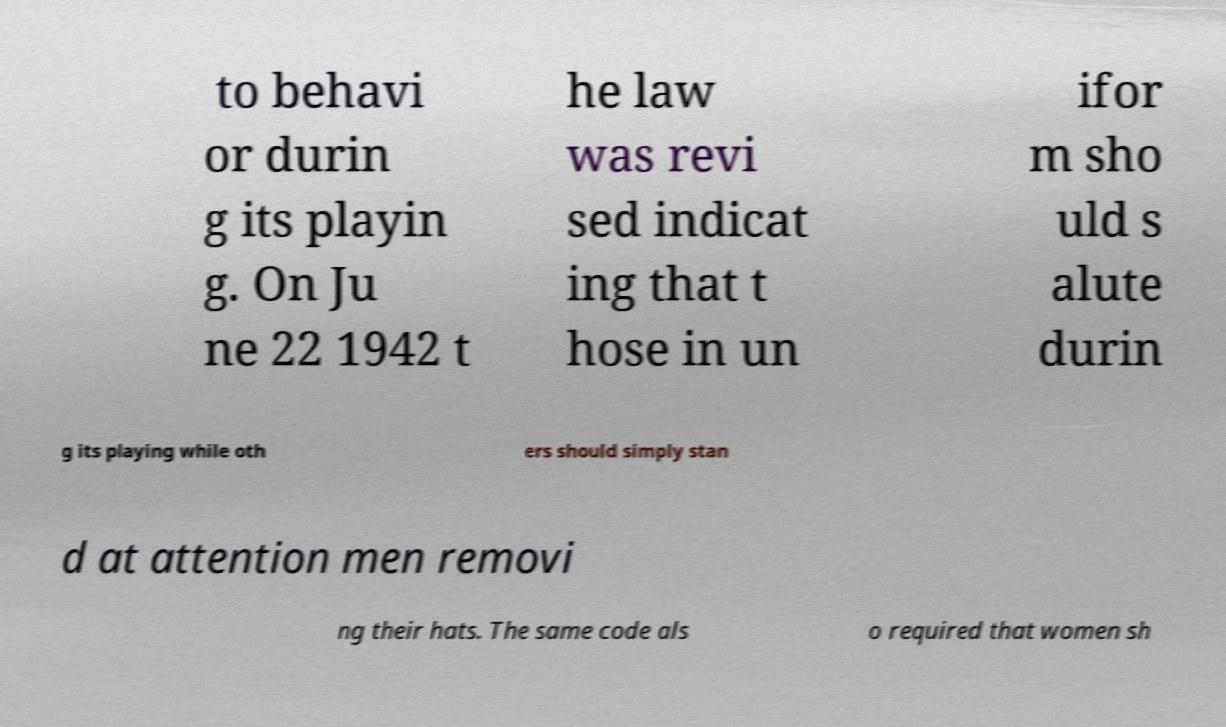Please read and relay the text visible in this image. What does it say? to behavi or durin g its playin g. On Ju ne 22 1942 t he law was revi sed indicat ing that t hose in un ifor m sho uld s alute durin g its playing while oth ers should simply stan d at attention men removi ng their hats. The same code als o required that women sh 